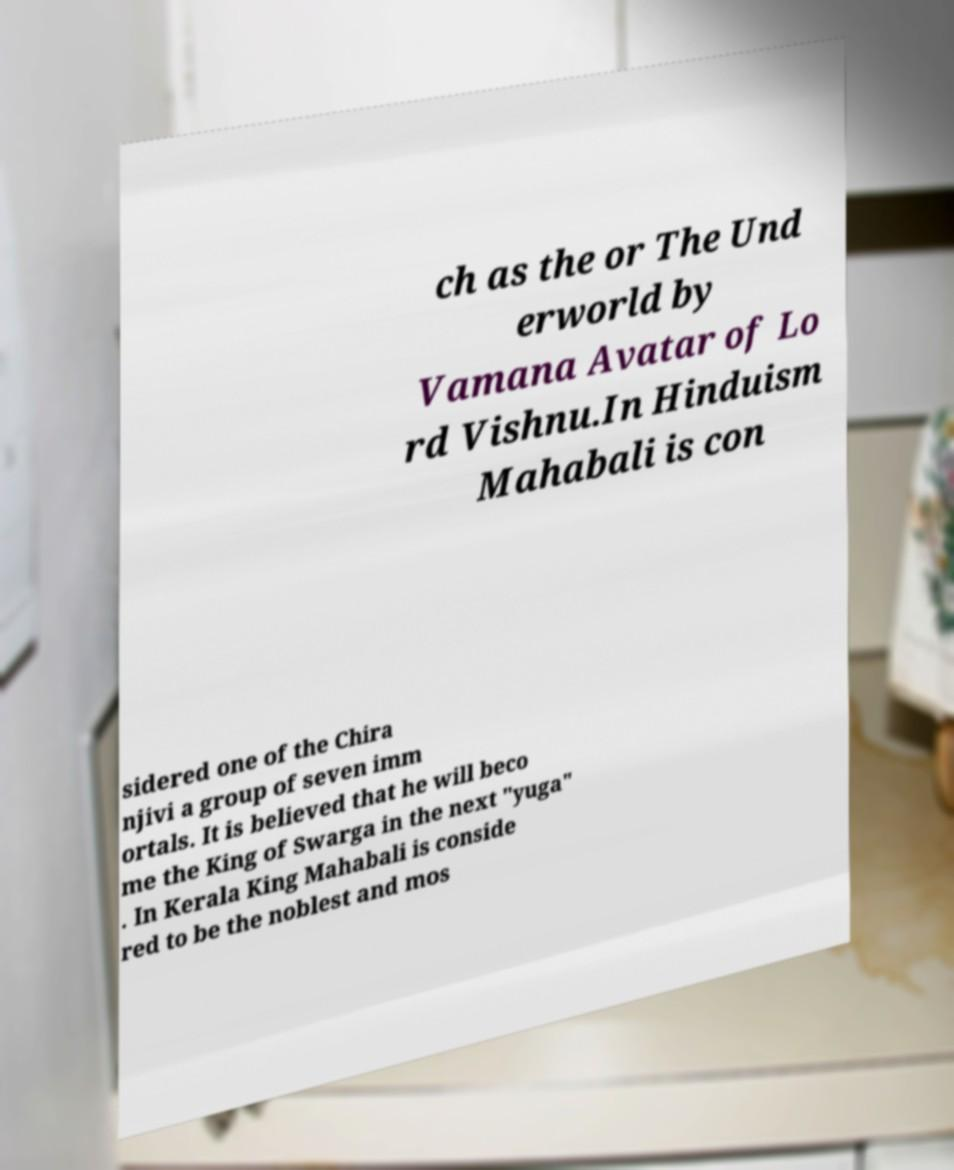What messages or text are displayed in this image? I need them in a readable, typed format. ch as the or The Und erworld by Vamana Avatar of Lo rd Vishnu.In Hinduism Mahabali is con sidered one of the Chira njivi a group of seven imm ortals. It is believed that he will beco me the King of Swarga in the next "yuga" . In Kerala King Mahabali is conside red to be the noblest and mos 